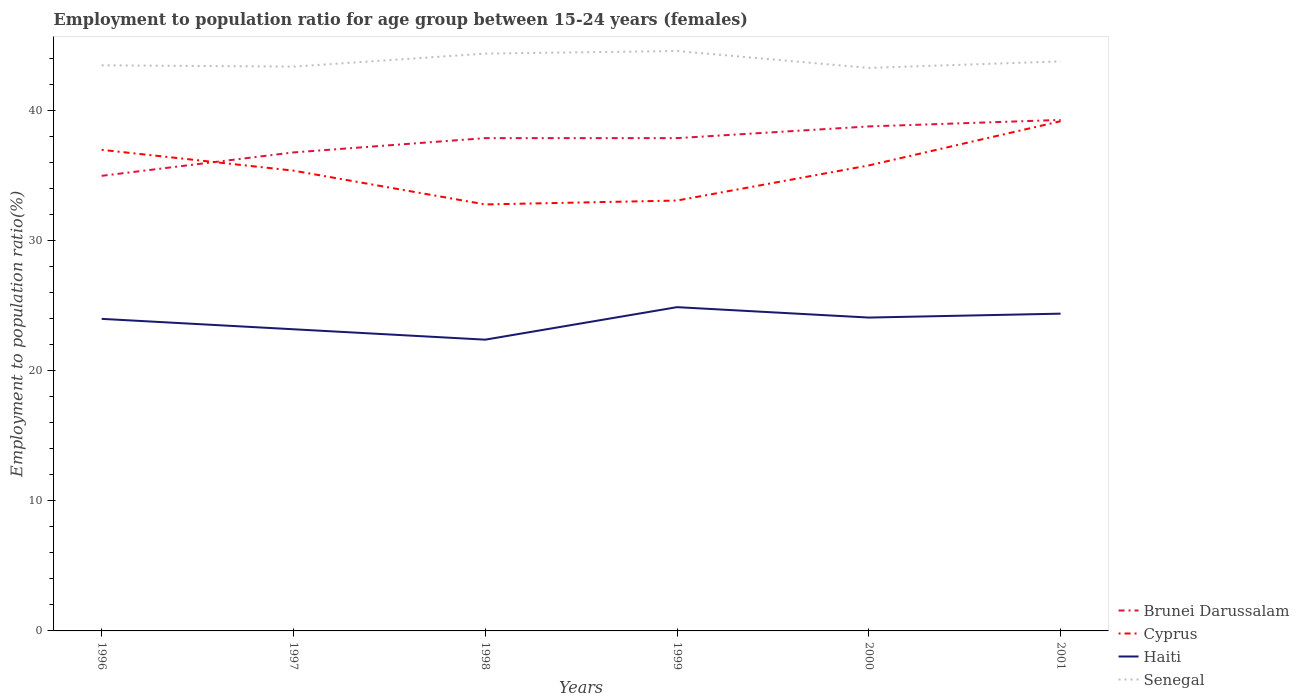How many different coloured lines are there?
Your answer should be compact. 4. In which year was the employment to population ratio in Brunei Darussalam maximum?
Give a very brief answer. 1996. What is the total employment to population ratio in Haiti in the graph?
Provide a short and direct response. 1.6. How many lines are there?
Offer a very short reply. 4. How many years are there in the graph?
Offer a terse response. 6. What is the difference between two consecutive major ticks on the Y-axis?
Your answer should be very brief. 10. Does the graph contain any zero values?
Offer a very short reply. No. Where does the legend appear in the graph?
Give a very brief answer. Bottom right. How many legend labels are there?
Keep it short and to the point. 4. How are the legend labels stacked?
Keep it short and to the point. Vertical. What is the title of the graph?
Your answer should be compact. Employment to population ratio for age group between 15-24 years (females). What is the Employment to population ratio(%) in Brunei Darussalam in 1996?
Offer a very short reply. 35. What is the Employment to population ratio(%) of Senegal in 1996?
Offer a terse response. 43.5. What is the Employment to population ratio(%) of Brunei Darussalam in 1997?
Provide a succinct answer. 36.8. What is the Employment to population ratio(%) of Cyprus in 1997?
Offer a terse response. 35.4. What is the Employment to population ratio(%) of Haiti in 1997?
Your answer should be very brief. 23.2. What is the Employment to population ratio(%) in Senegal in 1997?
Your response must be concise. 43.4. What is the Employment to population ratio(%) in Brunei Darussalam in 1998?
Offer a terse response. 37.9. What is the Employment to population ratio(%) in Cyprus in 1998?
Keep it short and to the point. 32.8. What is the Employment to population ratio(%) in Haiti in 1998?
Keep it short and to the point. 22.4. What is the Employment to population ratio(%) in Senegal in 1998?
Your answer should be very brief. 44.4. What is the Employment to population ratio(%) in Brunei Darussalam in 1999?
Keep it short and to the point. 37.9. What is the Employment to population ratio(%) of Cyprus in 1999?
Provide a short and direct response. 33.1. What is the Employment to population ratio(%) in Haiti in 1999?
Offer a terse response. 24.9. What is the Employment to population ratio(%) in Senegal in 1999?
Provide a succinct answer. 44.6. What is the Employment to population ratio(%) in Brunei Darussalam in 2000?
Provide a succinct answer. 38.8. What is the Employment to population ratio(%) of Cyprus in 2000?
Offer a terse response. 35.8. What is the Employment to population ratio(%) of Haiti in 2000?
Keep it short and to the point. 24.1. What is the Employment to population ratio(%) in Senegal in 2000?
Your answer should be compact. 43.3. What is the Employment to population ratio(%) of Brunei Darussalam in 2001?
Give a very brief answer. 39.3. What is the Employment to population ratio(%) of Cyprus in 2001?
Provide a short and direct response. 39.2. What is the Employment to population ratio(%) in Haiti in 2001?
Offer a very short reply. 24.4. What is the Employment to population ratio(%) in Senegal in 2001?
Offer a terse response. 43.8. Across all years, what is the maximum Employment to population ratio(%) in Brunei Darussalam?
Provide a succinct answer. 39.3. Across all years, what is the maximum Employment to population ratio(%) of Cyprus?
Offer a very short reply. 39.2. Across all years, what is the maximum Employment to population ratio(%) in Haiti?
Offer a very short reply. 24.9. Across all years, what is the maximum Employment to population ratio(%) in Senegal?
Offer a terse response. 44.6. Across all years, what is the minimum Employment to population ratio(%) of Brunei Darussalam?
Provide a succinct answer. 35. Across all years, what is the minimum Employment to population ratio(%) in Cyprus?
Your response must be concise. 32.8. Across all years, what is the minimum Employment to population ratio(%) in Haiti?
Give a very brief answer. 22.4. Across all years, what is the minimum Employment to population ratio(%) of Senegal?
Offer a terse response. 43.3. What is the total Employment to population ratio(%) of Brunei Darussalam in the graph?
Provide a short and direct response. 225.7. What is the total Employment to population ratio(%) in Cyprus in the graph?
Your response must be concise. 213.3. What is the total Employment to population ratio(%) in Haiti in the graph?
Provide a short and direct response. 143. What is the total Employment to population ratio(%) in Senegal in the graph?
Offer a terse response. 263. What is the difference between the Employment to population ratio(%) of Brunei Darussalam in 1996 and that in 1997?
Give a very brief answer. -1.8. What is the difference between the Employment to population ratio(%) in Haiti in 1996 and that in 1997?
Provide a short and direct response. 0.8. What is the difference between the Employment to population ratio(%) of Senegal in 1996 and that in 1997?
Give a very brief answer. 0.1. What is the difference between the Employment to population ratio(%) in Cyprus in 1996 and that in 1998?
Your response must be concise. 4.2. What is the difference between the Employment to population ratio(%) of Haiti in 1996 and that in 1998?
Keep it short and to the point. 1.6. What is the difference between the Employment to population ratio(%) in Brunei Darussalam in 1996 and that in 1999?
Give a very brief answer. -2.9. What is the difference between the Employment to population ratio(%) in Cyprus in 1996 and that in 1999?
Your answer should be very brief. 3.9. What is the difference between the Employment to population ratio(%) of Senegal in 1996 and that in 1999?
Keep it short and to the point. -1.1. What is the difference between the Employment to population ratio(%) in Brunei Darussalam in 1996 and that in 2000?
Provide a succinct answer. -3.8. What is the difference between the Employment to population ratio(%) of Haiti in 1996 and that in 2001?
Your answer should be very brief. -0.4. What is the difference between the Employment to population ratio(%) in Cyprus in 1997 and that in 1998?
Make the answer very short. 2.6. What is the difference between the Employment to population ratio(%) of Cyprus in 1997 and that in 1999?
Keep it short and to the point. 2.3. What is the difference between the Employment to population ratio(%) in Brunei Darussalam in 1997 and that in 2000?
Keep it short and to the point. -2. What is the difference between the Employment to population ratio(%) in Cyprus in 1997 and that in 2000?
Offer a terse response. -0.4. What is the difference between the Employment to population ratio(%) in Haiti in 1997 and that in 2000?
Offer a very short reply. -0.9. What is the difference between the Employment to population ratio(%) in Senegal in 1997 and that in 2000?
Provide a short and direct response. 0.1. What is the difference between the Employment to population ratio(%) in Brunei Darussalam in 1997 and that in 2001?
Provide a short and direct response. -2.5. What is the difference between the Employment to population ratio(%) in Haiti in 1998 and that in 1999?
Provide a short and direct response. -2.5. What is the difference between the Employment to population ratio(%) in Cyprus in 1998 and that in 2000?
Offer a very short reply. -3. What is the difference between the Employment to population ratio(%) in Haiti in 1998 and that in 2000?
Give a very brief answer. -1.7. What is the difference between the Employment to population ratio(%) of Brunei Darussalam in 1998 and that in 2001?
Make the answer very short. -1.4. What is the difference between the Employment to population ratio(%) of Senegal in 1998 and that in 2001?
Your answer should be very brief. 0.6. What is the difference between the Employment to population ratio(%) of Cyprus in 1999 and that in 2000?
Offer a terse response. -2.7. What is the difference between the Employment to population ratio(%) in Cyprus in 1999 and that in 2001?
Offer a terse response. -6.1. What is the difference between the Employment to population ratio(%) of Brunei Darussalam in 2000 and that in 2001?
Keep it short and to the point. -0.5. What is the difference between the Employment to population ratio(%) in Cyprus in 2000 and that in 2001?
Make the answer very short. -3.4. What is the difference between the Employment to population ratio(%) of Haiti in 2000 and that in 2001?
Your answer should be very brief. -0.3. What is the difference between the Employment to population ratio(%) in Brunei Darussalam in 1996 and the Employment to population ratio(%) in Haiti in 1997?
Make the answer very short. 11.8. What is the difference between the Employment to population ratio(%) of Brunei Darussalam in 1996 and the Employment to population ratio(%) of Senegal in 1997?
Your answer should be compact. -8.4. What is the difference between the Employment to population ratio(%) in Cyprus in 1996 and the Employment to population ratio(%) in Haiti in 1997?
Your answer should be very brief. 13.8. What is the difference between the Employment to population ratio(%) in Cyprus in 1996 and the Employment to population ratio(%) in Senegal in 1997?
Your answer should be very brief. -6.4. What is the difference between the Employment to population ratio(%) of Haiti in 1996 and the Employment to population ratio(%) of Senegal in 1997?
Provide a short and direct response. -19.4. What is the difference between the Employment to population ratio(%) of Brunei Darussalam in 1996 and the Employment to population ratio(%) of Cyprus in 1998?
Keep it short and to the point. 2.2. What is the difference between the Employment to population ratio(%) of Brunei Darussalam in 1996 and the Employment to population ratio(%) of Haiti in 1998?
Offer a very short reply. 12.6. What is the difference between the Employment to population ratio(%) in Haiti in 1996 and the Employment to population ratio(%) in Senegal in 1998?
Offer a terse response. -20.4. What is the difference between the Employment to population ratio(%) in Brunei Darussalam in 1996 and the Employment to population ratio(%) in Cyprus in 1999?
Provide a short and direct response. 1.9. What is the difference between the Employment to population ratio(%) of Brunei Darussalam in 1996 and the Employment to population ratio(%) of Haiti in 1999?
Ensure brevity in your answer.  10.1. What is the difference between the Employment to population ratio(%) in Brunei Darussalam in 1996 and the Employment to population ratio(%) in Senegal in 1999?
Offer a terse response. -9.6. What is the difference between the Employment to population ratio(%) of Haiti in 1996 and the Employment to population ratio(%) of Senegal in 1999?
Keep it short and to the point. -20.6. What is the difference between the Employment to population ratio(%) of Brunei Darussalam in 1996 and the Employment to population ratio(%) of Haiti in 2000?
Provide a succinct answer. 10.9. What is the difference between the Employment to population ratio(%) of Cyprus in 1996 and the Employment to population ratio(%) of Haiti in 2000?
Make the answer very short. 12.9. What is the difference between the Employment to population ratio(%) in Cyprus in 1996 and the Employment to population ratio(%) in Senegal in 2000?
Give a very brief answer. -6.3. What is the difference between the Employment to population ratio(%) of Haiti in 1996 and the Employment to population ratio(%) of Senegal in 2000?
Offer a terse response. -19.3. What is the difference between the Employment to population ratio(%) of Cyprus in 1996 and the Employment to population ratio(%) of Haiti in 2001?
Offer a terse response. 12.6. What is the difference between the Employment to population ratio(%) in Haiti in 1996 and the Employment to population ratio(%) in Senegal in 2001?
Your answer should be compact. -19.8. What is the difference between the Employment to population ratio(%) in Brunei Darussalam in 1997 and the Employment to population ratio(%) in Haiti in 1998?
Ensure brevity in your answer.  14.4. What is the difference between the Employment to population ratio(%) in Brunei Darussalam in 1997 and the Employment to population ratio(%) in Senegal in 1998?
Offer a very short reply. -7.6. What is the difference between the Employment to population ratio(%) in Cyprus in 1997 and the Employment to population ratio(%) in Senegal in 1998?
Keep it short and to the point. -9. What is the difference between the Employment to population ratio(%) in Haiti in 1997 and the Employment to population ratio(%) in Senegal in 1998?
Offer a terse response. -21.2. What is the difference between the Employment to population ratio(%) in Brunei Darussalam in 1997 and the Employment to population ratio(%) in Haiti in 1999?
Provide a succinct answer. 11.9. What is the difference between the Employment to population ratio(%) of Brunei Darussalam in 1997 and the Employment to population ratio(%) of Senegal in 1999?
Give a very brief answer. -7.8. What is the difference between the Employment to population ratio(%) of Cyprus in 1997 and the Employment to population ratio(%) of Haiti in 1999?
Provide a short and direct response. 10.5. What is the difference between the Employment to population ratio(%) in Haiti in 1997 and the Employment to population ratio(%) in Senegal in 1999?
Keep it short and to the point. -21.4. What is the difference between the Employment to population ratio(%) of Brunei Darussalam in 1997 and the Employment to population ratio(%) of Haiti in 2000?
Provide a short and direct response. 12.7. What is the difference between the Employment to population ratio(%) of Cyprus in 1997 and the Employment to population ratio(%) of Senegal in 2000?
Ensure brevity in your answer.  -7.9. What is the difference between the Employment to population ratio(%) of Haiti in 1997 and the Employment to population ratio(%) of Senegal in 2000?
Give a very brief answer. -20.1. What is the difference between the Employment to population ratio(%) of Brunei Darussalam in 1997 and the Employment to population ratio(%) of Cyprus in 2001?
Offer a terse response. -2.4. What is the difference between the Employment to population ratio(%) in Brunei Darussalam in 1997 and the Employment to population ratio(%) in Senegal in 2001?
Ensure brevity in your answer.  -7. What is the difference between the Employment to population ratio(%) of Haiti in 1997 and the Employment to population ratio(%) of Senegal in 2001?
Ensure brevity in your answer.  -20.6. What is the difference between the Employment to population ratio(%) of Brunei Darussalam in 1998 and the Employment to population ratio(%) of Haiti in 1999?
Your answer should be very brief. 13. What is the difference between the Employment to population ratio(%) in Brunei Darussalam in 1998 and the Employment to population ratio(%) in Senegal in 1999?
Make the answer very short. -6.7. What is the difference between the Employment to population ratio(%) in Haiti in 1998 and the Employment to population ratio(%) in Senegal in 1999?
Provide a short and direct response. -22.2. What is the difference between the Employment to population ratio(%) of Haiti in 1998 and the Employment to population ratio(%) of Senegal in 2000?
Make the answer very short. -20.9. What is the difference between the Employment to population ratio(%) of Brunei Darussalam in 1998 and the Employment to population ratio(%) of Senegal in 2001?
Offer a very short reply. -5.9. What is the difference between the Employment to population ratio(%) in Cyprus in 1998 and the Employment to population ratio(%) in Haiti in 2001?
Your answer should be compact. 8.4. What is the difference between the Employment to population ratio(%) in Cyprus in 1998 and the Employment to population ratio(%) in Senegal in 2001?
Provide a succinct answer. -11. What is the difference between the Employment to population ratio(%) in Haiti in 1998 and the Employment to population ratio(%) in Senegal in 2001?
Provide a short and direct response. -21.4. What is the difference between the Employment to population ratio(%) in Brunei Darussalam in 1999 and the Employment to population ratio(%) in Cyprus in 2000?
Ensure brevity in your answer.  2.1. What is the difference between the Employment to population ratio(%) in Cyprus in 1999 and the Employment to population ratio(%) in Senegal in 2000?
Keep it short and to the point. -10.2. What is the difference between the Employment to population ratio(%) of Haiti in 1999 and the Employment to population ratio(%) of Senegal in 2000?
Keep it short and to the point. -18.4. What is the difference between the Employment to population ratio(%) of Brunei Darussalam in 1999 and the Employment to population ratio(%) of Cyprus in 2001?
Make the answer very short. -1.3. What is the difference between the Employment to population ratio(%) of Brunei Darussalam in 1999 and the Employment to population ratio(%) of Senegal in 2001?
Provide a succinct answer. -5.9. What is the difference between the Employment to population ratio(%) of Haiti in 1999 and the Employment to population ratio(%) of Senegal in 2001?
Offer a terse response. -18.9. What is the difference between the Employment to population ratio(%) in Brunei Darussalam in 2000 and the Employment to population ratio(%) in Haiti in 2001?
Provide a short and direct response. 14.4. What is the difference between the Employment to population ratio(%) in Cyprus in 2000 and the Employment to population ratio(%) in Haiti in 2001?
Your answer should be very brief. 11.4. What is the difference between the Employment to population ratio(%) in Cyprus in 2000 and the Employment to population ratio(%) in Senegal in 2001?
Provide a short and direct response. -8. What is the difference between the Employment to population ratio(%) in Haiti in 2000 and the Employment to population ratio(%) in Senegal in 2001?
Your answer should be very brief. -19.7. What is the average Employment to population ratio(%) in Brunei Darussalam per year?
Your answer should be very brief. 37.62. What is the average Employment to population ratio(%) of Cyprus per year?
Ensure brevity in your answer.  35.55. What is the average Employment to population ratio(%) of Haiti per year?
Give a very brief answer. 23.83. What is the average Employment to population ratio(%) of Senegal per year?
Ensure brevity in your answer.  43.83. In the year 1996, what is the difference between the Employment to population ratio(%) in Cyprus and Employment to population ratio(%) in Haiti?
Offer a very short reply. 13. In the year 1996, what is the difference between the Employment to population ratio(%) in Cyprus and Employment to population ratio(%) in Senegal?
Offer a very short reply. -6.5. In the year 1996, what is the difference between the Employment to population ratio(%) in Haiti and Employment to population ratio(%) in Senegal?
Provide a short and direct response. -19.5. In the year 1997, what is the difference between the Employment to population ratio(%) in Brunei Darussalam and Employment to population ratio(%) in Haiti?
Offer a terse response. 13.6. In the year 1997, what is the difference between the Employment to population ratio(%) in Cyprus and Employment to population ratio(%) in Haiti?
Your answer should be compact. 12.2. In the year 1997, what is the difference between the Employment to population ratio(%) of Cyprus and Employment to population ratio(%) of Senegal?
Offer a very short reply. -8. In the year 1997, what is the difference between the Employment to population ratio(%) of Haiti and Employment to population ratio(%) of Senegal?
Offer a terse response. -20.2. In the year 1998, what is the difference between the Employment to population ratio(%) in Cyprus and Employment to population ratio(%) in Senegal?
Your response must be concise. -11.6. In the year 1999, what is the difference between the Employment to population ratio(%) of Brunei Darussalam and Employment to population ratio(%) of Cyprus?
Offer a very short reply. 4.8. In the year 1999, what is the difference between the Employment to population ratio(%) of Brunei Darussalam and Employment to population ratio(%) of Senegal?
Keep it short and to the point. -6.7. In the year 1999, what is the difference between the Employment to population ratio(%) of Cyprus and Employment to population ratio(%) of Haiti?
Your answer should be compact. 8.2. In the year 1999, what is the difference between the Employment to population ratio(%) of Haiti and Employment to population ratio(%) of Senegal?
Your answer should be compact. -19.7. In the year 2000, what is the difference between the Employment to population ratio(%) in Brunei Darussalam and Employment to population ratio(%) in Cyprus?
Give a very brief answer. 3. In the year 2000, what is the difference between the Employment to population ratio(%) in Cyprus and Employment to population ratio(%) in Senegal?
Provide a short and direct response. -7.5. In the year 2000, what is the difference between the Employment to population ratio(%) of Haiti and Employment to population ratio(%) of Senegal?
Give a very brief answer. -19.2. In the year 2001, what is the difference between the Employment to population ratio(%) in Brunei Darussalam and Employment to population ratio(%) in Cyprus?
Your answer should be compact. 0.1. In the year 2001, what is the difference between the Employment to population ratio(%) of Cyprus and Employment to population ratio(%) of Haiti?
Ensure brevity in your answer.  14.8. In the year 2001, what is the difference between the Employment to population ratio(%) of Cyprus and Employment to population ratio(%) of Senegal?
Keep it short and to the point. -4.6. In the year 2001, what is the difference between the Employment to population ratio(%) in Haiti and Employment to population ratio(%) in Senegal?
Make the answer very short. -19.4. What is the ratio of the Employment to population ratio(%) of Brunei Darussalam in 1996 to that in 1997?
Make the answer very short. 0.95. What is the ratio of the Employment to population ratio(%) in Cyprus in 1996 to that in 1997?
Ensure brevity in your answer.  1.05. What is the ratio of the Employment to population ratio(%) of Haiti in 1996 to that in 1997?
Your answer should be compact. 1.03. What is the ratio of the Employment to population ratio(%) in Senegal in 1996 to that in 1997?
Your response must be concise. 1. What is the ratio of the Employment to population ratio(%) in Brunei Darussalam in 1996 to that in 1998?
Keep it short and to the point. 0.92. What is the ratio of the Employment to population ratio(%) in Cyprus in 1996 to that in 1998?
Keep it short and to the point. 1.13. What is the ratio of the Employment to population ratio(%) of Haiti in 1996 to that in 1998?
Give a very brief answer. 1.07. What is the ratio of the Employment to population ratio(%) of Senegal in 1996 to that in 1998?
Provide a short and direct response. 0.98. What is the ratio of the Employment to population ratio(%) in Brunei Darussalam in 1996 to that in 1999?
Make the answer very short. 0.92. What is the ratio of the Employment to population ratio(%) of Cyprus in 1996 to that in 1999?
Make the answer very short. 1.12. What is the ratio of the Employment to population ratio(%) in Haiti in 1996 to that in 1999?
Ensure brevity in your answer.  0.96. What is the ratio of the Employment to population ratio(%) in Senegal in 1996 to that in 1999?
Provide a short and direct response. 0.98. What is the ratio of the Employment to population ratio(%) in Brunei Darussalam in 1996 to that in 2000?
Keep it short and to the point. 0.9. What is the ratio of the Employment to population ratio(%) of Cyprus in 1996 to that in 2000?
Your answer should be very brief. 1.03. What is the ratio of the Employment to population ratio(%) of Haiti in 1996 to that in 2000?
Make the answer very short. 1. What is the ratio of the Employment to population ratio(%) of Brunei Darussalam in 1996 to that in 2001?
Give a very brief answer. 0.89. What is the ratio of the Employment to population ratio(%) of Cyprus in 1996 to that in 2001?
Offer a terse response. 0.94. What is the ratio of the Employment to population ratio(%) of Haiti in 1996 to that in 2001?
Ensure brevity in your answer.  0.98. What is the ratio of the Employment to population ratio(%) of Cyprus in 1997 to that in 1998?
Offer a very short reply. 1.08. What is the ratio of the Employment to population ratio(%) in Haiti in 1997 to that in 1998?
Your answer should be very brief. 1.04. What is the ratio of the Employment to population ratio(%) of Senegal in 1997 to that in 1998?
Make the answer very short. 0.98. What is the ratio of the Employment to population ratio(%) in Brunei Darussalam in 1997 to that in 1999?
Make the answer very short. 0.97. What is the ratio of the Employment to population ratio(%) of Cyprus in 1997 to that in 1999?
Offer a terse response. 1.07. What is the ratio of the Employment to population ratio(%) of Haiti in 1997 to that in 1999?
Give a very brief answer. 0.93. What is the ratio of the Employment to population ratio(%) of Senegal in 1997 to that in 1999?
Offer a terse response. 0.97. What is the ratio of the Employment to population ratio(%) in Brunei Darussalam in 1997 to that in 2000?
Offer a very short reply. 0.95. What is the ratio of the Employment to population ratio(%) of Cyprus in 1997 to that in 2000?
Your answer should be very brief. 0.99. What is the ratio of the Employment to population ratio(%) of Haiti in 1997 to that in 2000?
Keep it short and to the point. 0.96. What is the ratio of the Employment to population ratio(%) in Senegal in 1997 to that in 2000?
Your answer should be compact. 1. What is the ratio of the Employment to population ratio(%) of Brunei Darussalam in 1997 to that in 2001?
Offer a very short reply. 0.94. What is the ratio of the Employment to population ratio(%) in Cyprus in 1997 to that in 2001?
Provide a short and direct response. 0.9. What is the ratio of the Employment to population ratio(%) in Haiti in 1997 to that in 2001?
Make the answer very short. 0.95. What is the ratio of the Employment to population ratio(%) of Senegal in 1997 to that in 2001?
Your response must be concise. 0.99. What is the ratio of the Employment to population ratio(%) of Cyprus in 1998 to that in 1999?
Provide a succinct answer. 0.99. What is the ratio of the Employment to population ratio(%) of Haiti in 1998 to that in 1999?
Your answer should be very brief. 0.9. What is the ratio of the Employment to population ratio(%) of Senegal in 1998 to that in 1999?
Make the answer very short. 1. What is the ratio of the Employment to population ratio(%) of Brunei Darussalam in 1998 to that in 2000?
Ensure brevity in your answer.  0.98. What is the ratio of the Employment to population ratio(%) in Cyprus in 1998 to that in 2000?
Your answer should be very brief. 0.92. What is the ratio of the Employment to population ratio(%) of Haiti in 1998 to that in 2000?
Provide a succinct answer. 0.93. What is the ratio of the Employment to population ratio(%) of Senegal in 1998 to that in 2000?
Your answer should be compact. 1.03. What is the ratio of the Employment to population ratio(%) in Brunei Darussalam in 1998 to that in 2001?
Your answer should be very brief. 0.96. What is the ratio of the Employment to population ratio(%) of Cyprus in 1998 to that in 2001?
Provide a short and direct response. 0.84. What is the ratio of the Employment to population ratio(%) of Haiti in 1998 to that in 2001?
Ensure brevity in your answer.  0.92. What is the ratio of the Employment to population ratio(%) of Senegal in 1998 to that in 2001?
Offer a very short reply. 1.01. What is the ratio of the Employment to population ratio(%) in Brunei Darussalam in 1999 to that in 2000?
Keep it short and to the point. 0.98. What is the ratio of the Employment to population ratio(%) of Cyprus in 1999 to that in 2000?
Your answer should be very brief. 0.92. What is the ratio of the Employment to population ratio(%) of Haiti in 1999 to that in 2000?
Make the answer very short. 1.03. What is the ratio of the Employment to population ratio(%) in Senegal in 1999 to that in 2000?
Give a very brief answer. 1.03. What is the ratio of the Employment to population ratio(%) of Brunei Darussalam in 1999 to that in 2001?
Keep it short and to the point. 0.96. What is the ratio of the Employment to population ratio(%) in Cyprus in 1999 to that in 2001?
Your answer should be compact. 0.84. What is the ratio of the Employment to population ratio(%) in Haiti in 1999 to that in 2001?
Keep it short and to the point. 1.02. What is the ratio of the Employment to population ratio(%) of Senegal in 1999 to that in 2001?
Your response must be concise. 1.02. What is the ratio of the Employment to population ratio(%) of Brunei Darussalam in 2000 to that in 2001?
Provide a succinct answer. 0.99. What is the ratio of the Employment to population ratio(%) of Cyprus in 2000 to that in 2001?
Your response must be concise. 0.91. What is the ratio of the Employment to population ratio(%) of Haiti in 2000 to that in 2001?
Offer a very short reply. 0.99. What is the difference between the highest and the second highest Employment to population ratio(%) of Brunei Darussalam?
Make the answer very short. 0.5. What is the difference between the highest and the second highest Employment to population ratio(%) of Cyprus?
Keep it short and to the point. 2.2. What is the difference between the highest and the second highest Employment to population ratio(%) in Haiti?
Ensure brevity in your answer.  0.5. What is the difference between the highest and the lowest Employment to population ratio(%) of Brunei Darussalam?
Make the answer very short. 4.3. What is the difference between the highest and the lowest Employment to population ratio(%) of Haiti?
Your response must be concise. 2.5. 